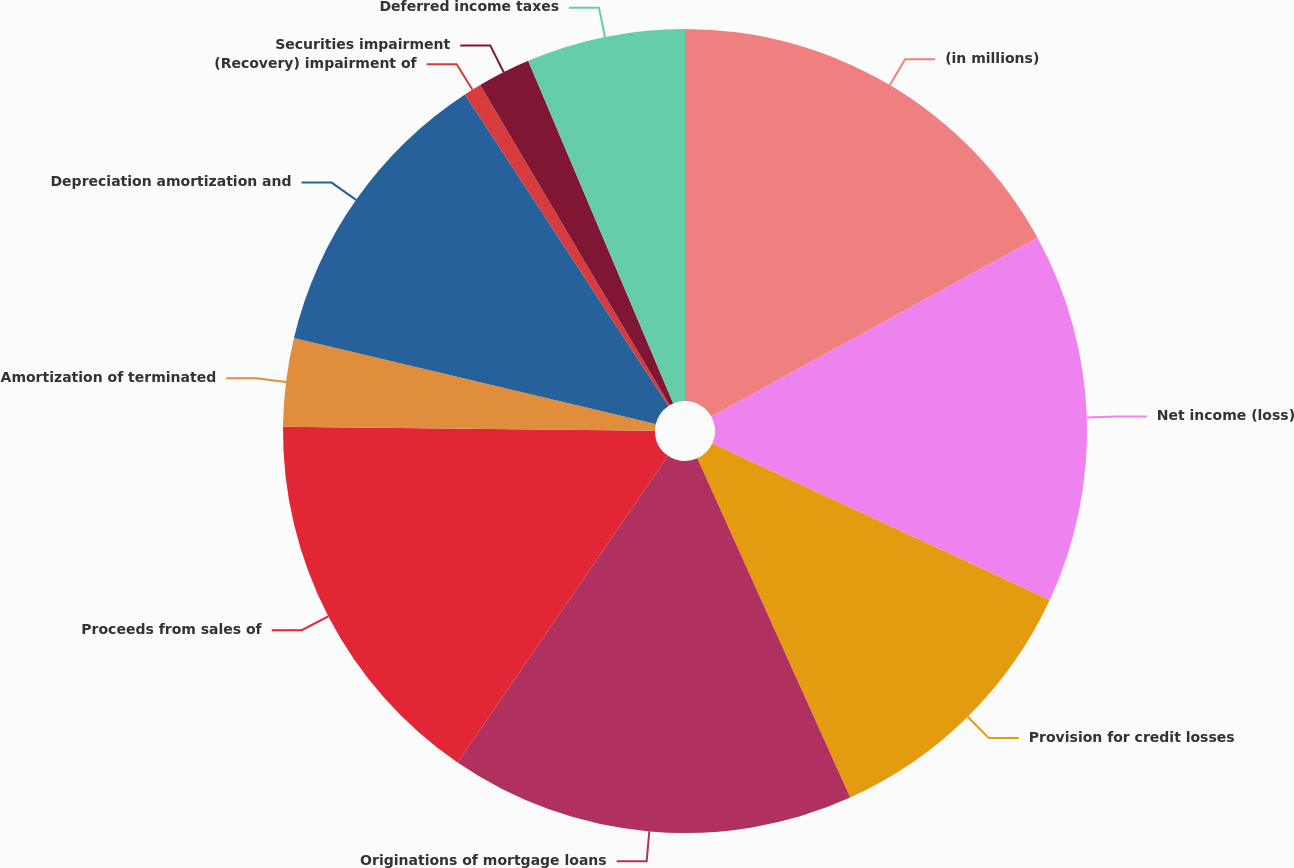Convert chart. <chart><loc_0><loc_0><loc_500><loc_500><pie_chart><fcel>(in millions)<fcel>Net income (loss)<fcel>Provision for credit losses<fcel>Originations of mortgage loans<fcel>Proceeds from sales of<fcel>Amortization of terminated<fcel>Depreciation amortization and<fcel>(Recovery) impairment of<fcel>Securities impairment<fcel>Deferred income taxes<nl><fcel>17.02%<fcel>14.89%<fcel>11.35%<fcel>16.31%<fcel>15.6%<fcel>3.55%<fcel>12.06%<fcel>0.71%<fcel>2.13%<fcel>6.38%<nl></chart> 